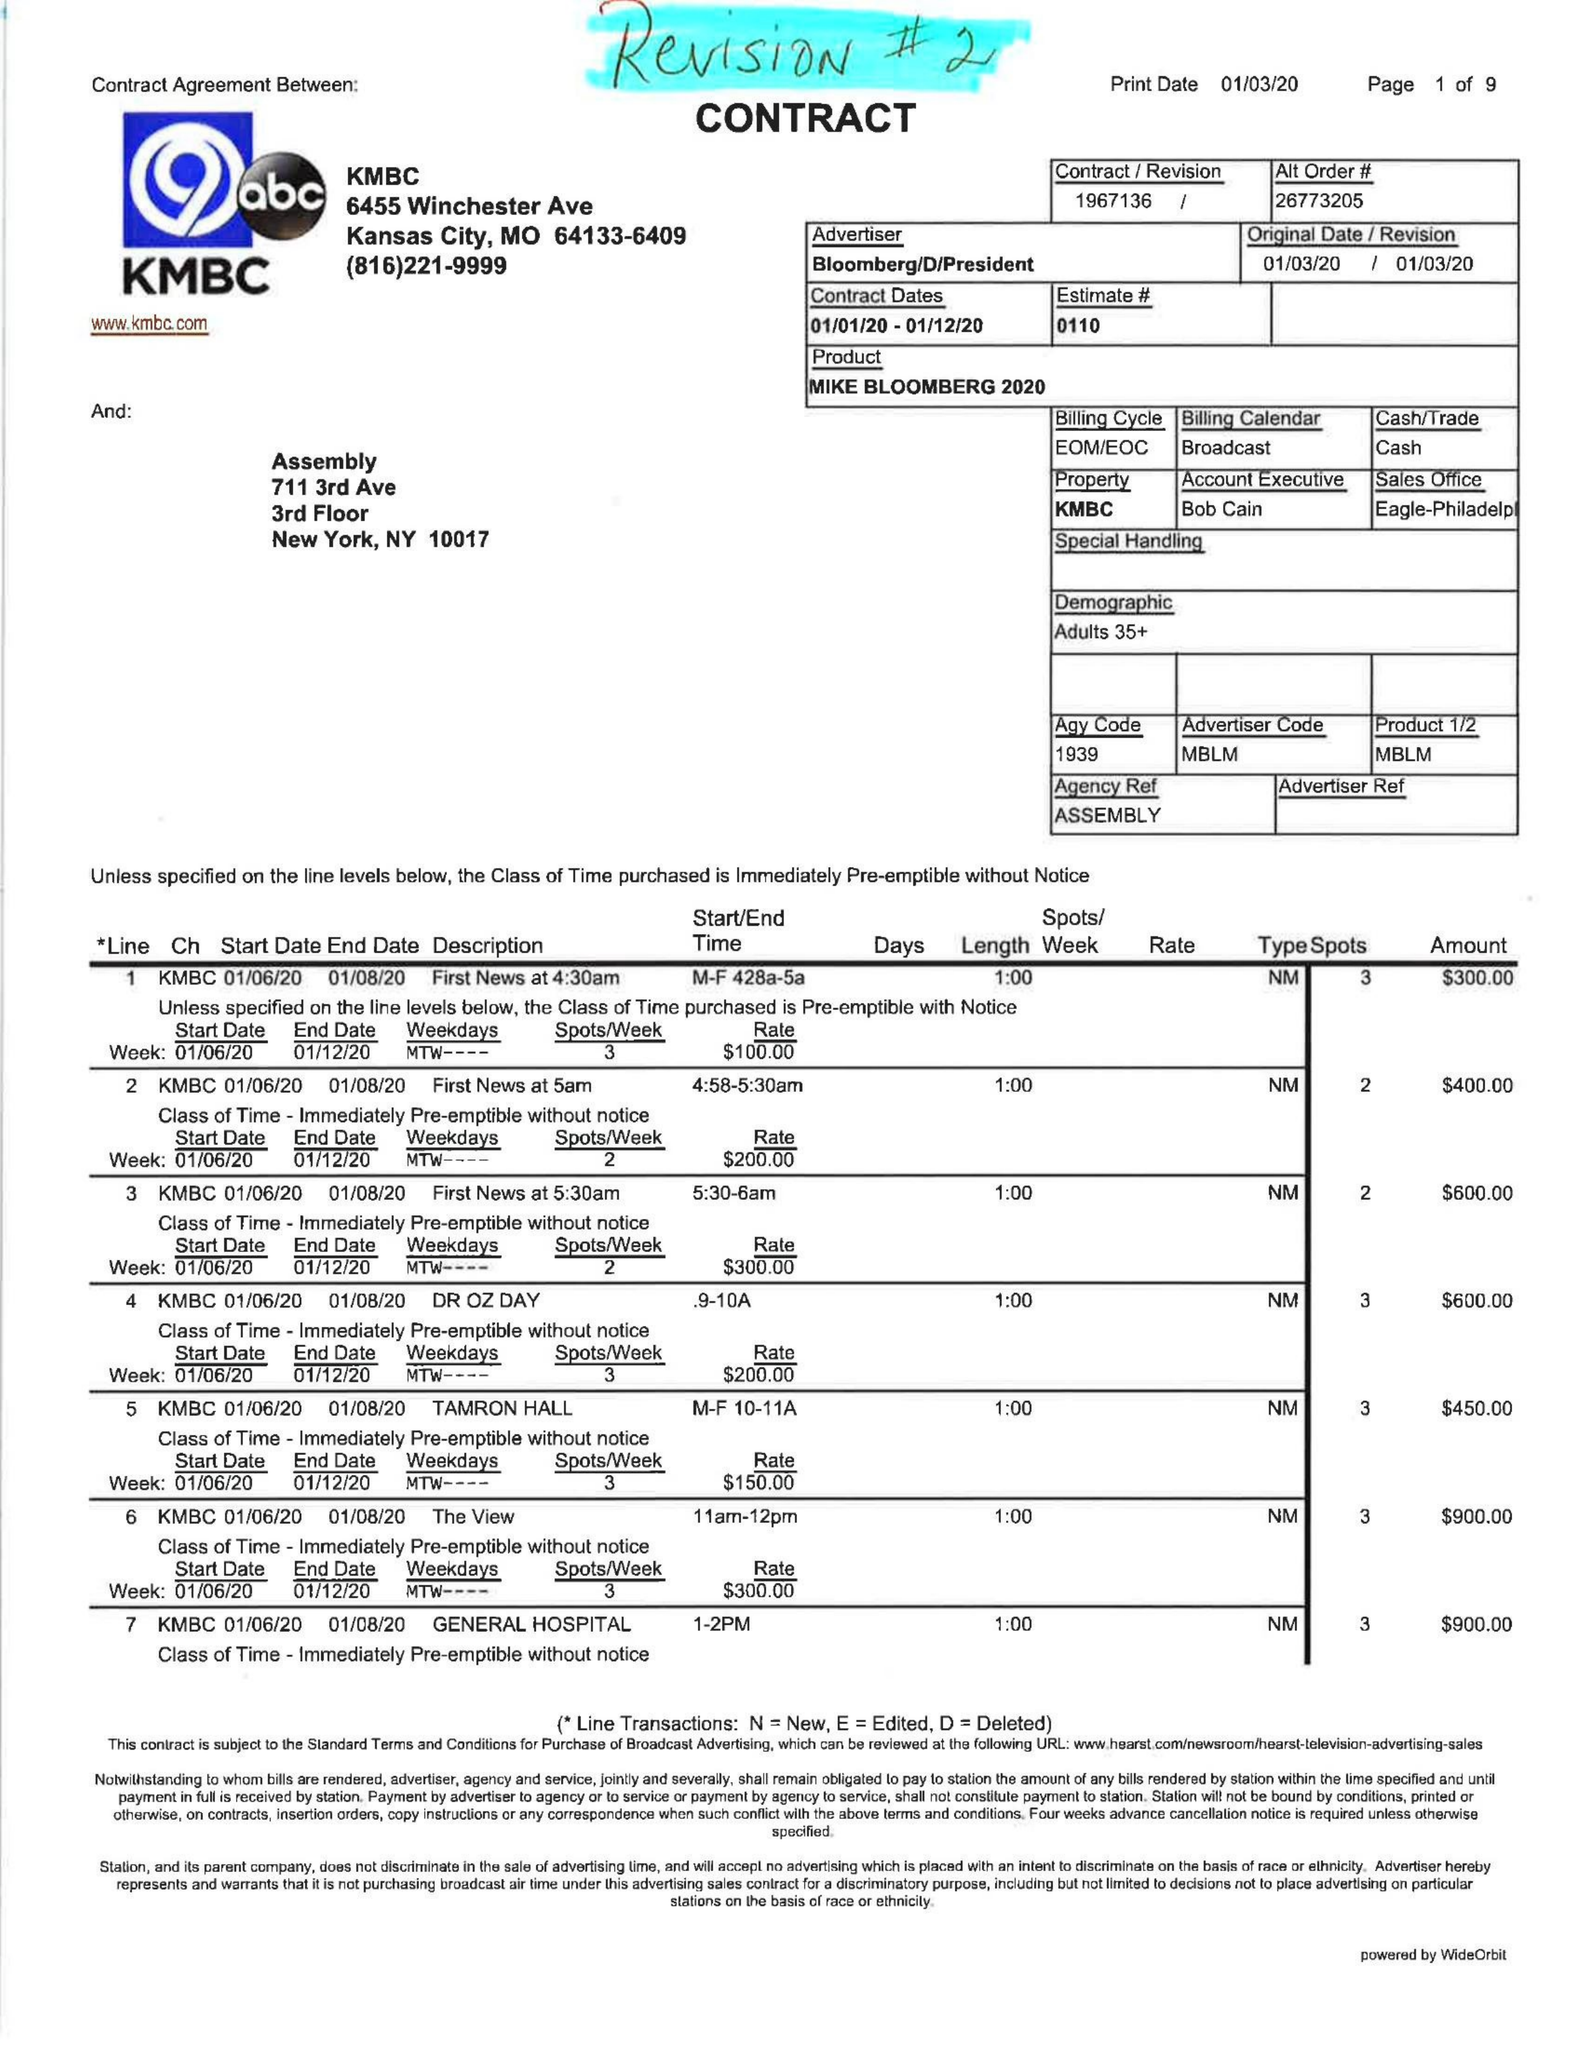What is the value for the contract_num?
Answer the question using a single word or phrase. 1967136 